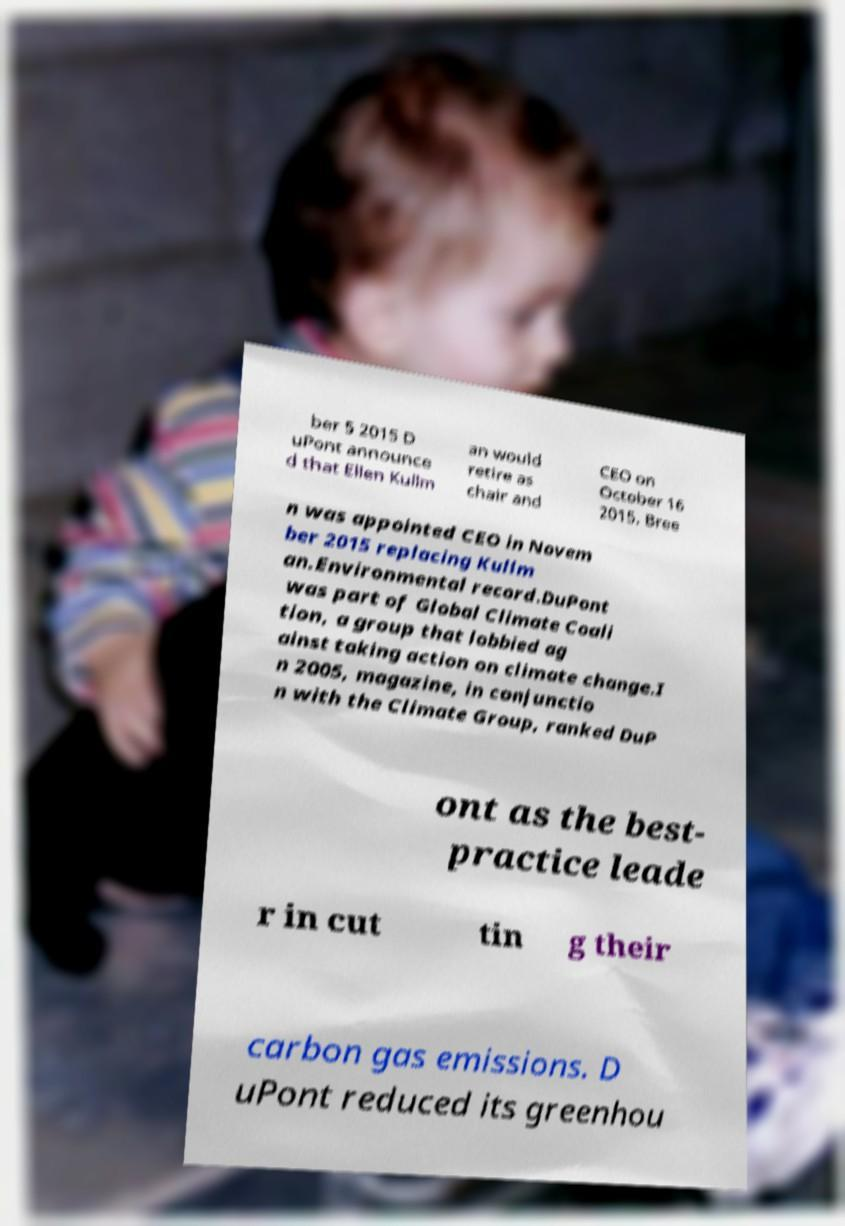Please read and relay the text visible in this image. What does it say? ber 5 2015 D uPont announce d that Ellen Kullm an would retire as chair and CEO on October 16 2015. Bree n was appointed CEO in Novem ber 2015 replacing Kullm an.Environmental record.DuPont was part of Global Climate Coali tion, a group that lobbied ag ainst taking action on climate change.I n 2005, magazine, in conjunctio n with the Climate Group, ranked DuP ont as the best- practice leade r in cut tin g their carbon gas emissions. D uPont reduced its greenhou 